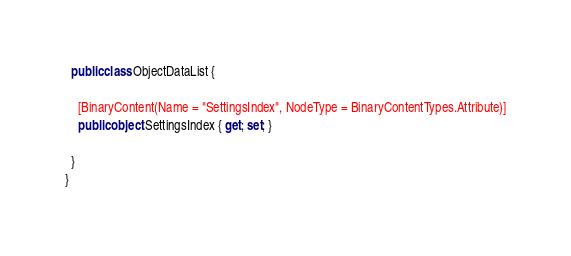<code> <loc_0><loc_0><loc_500><loc_500><_C#_>
  public class ObjectDataList {

    [BinaryContent(Name = "SettingsIndex", NodeType = BinaryContentTypes.Attribute)]
    public object SettingsIndex { get; set; }

  }
}</code> 